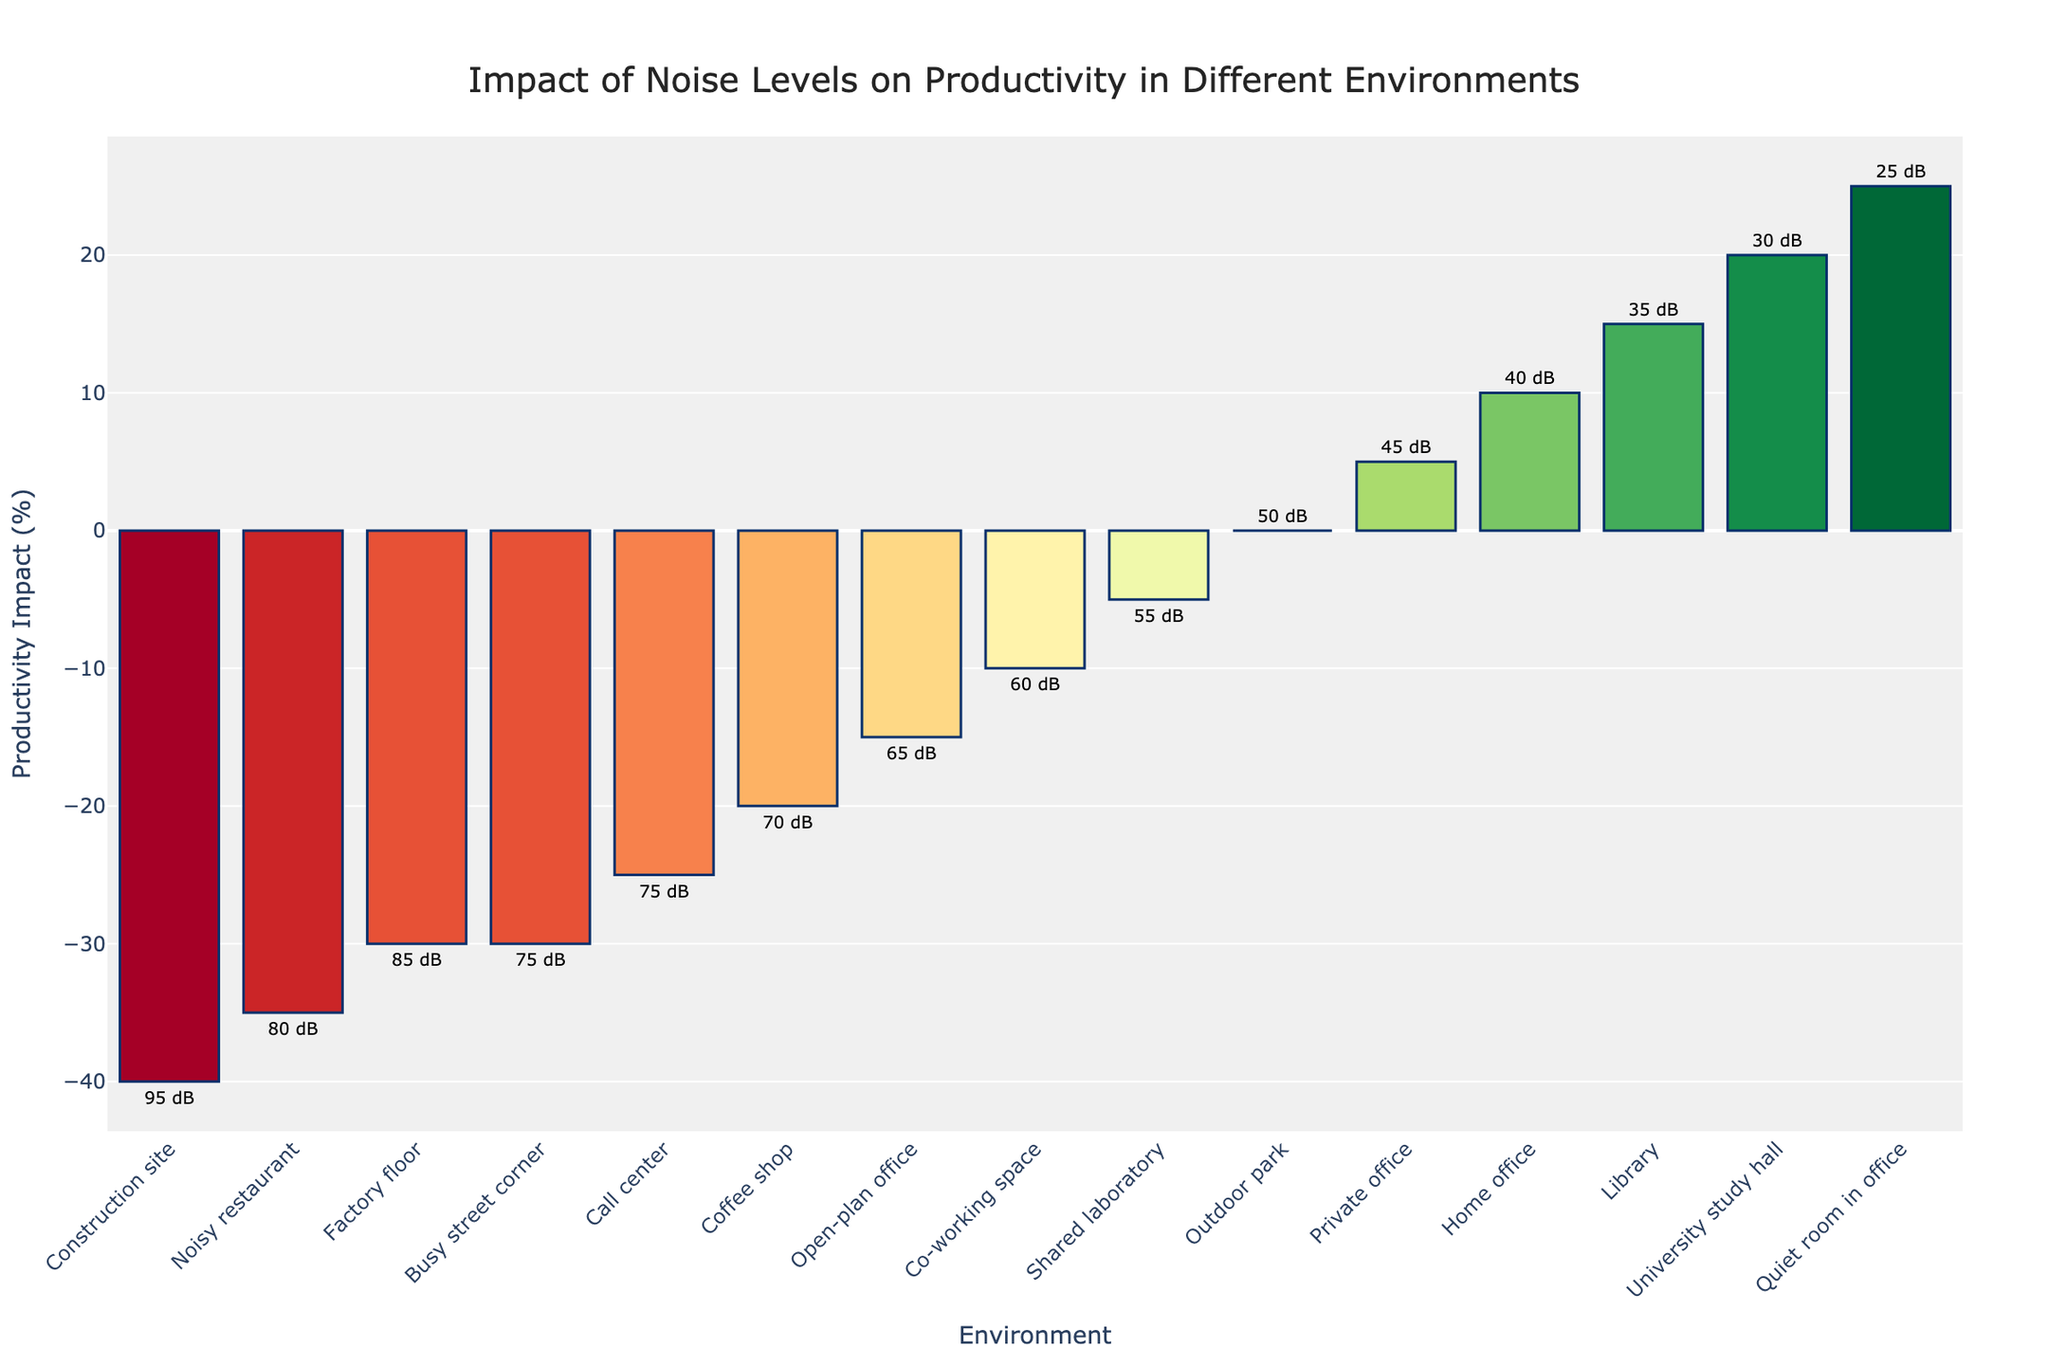Which environment has the highest positive impact on productivity? Look at the environment with the highest bar extending in the positive direction. The "University study hall" has the highest positive productivity impact.
Answer: University study hall Which environment has the lowest negative impact on productivity? Look at the environment with the least bar extending in the negative direction. The "Open-plan office" has the lowest negative productivity impact.
Answer: Open-plan office What is the difference in productivity impact between a private office and a shared laboratory? Find the bars for "Private office" and "Shared laboratory" and calculate the difference in their productivity impacts: 5 - (-5) = 10%.
Answer: 10% How much does productivity increase in a home office compared to a co-working space? Find the bars for "Home office" and "Co-working space" and calculate the difference in their productivity impacts: 10 - (-10) = 20%.
Answer: 20% What environments have a noise level of 70 dB or higher? Find the environments with text labels of 70 dB or higher: "Coffee shop", "Call center", "Construction site", "Noisy restaurant", "Busy street corner".
Answer: Coffee shop, Call center, Construction site, Noisy restaurant, Busy street corner Which environment has the greatest noise level but still shows positive productivity impact? Look for the environment with the highest noise level (dB) among those with positive productivity impact. The "Library" has 35 dB and +15% impact.
Answer: Library Compare the productivity impacts between the University study hall and the Construction site. Find and compare the values for "University study hall" and "Construction site". The productivity impact difference is 20 - (-40) = 60%.
Answer: 60% What’s the average productivity impact of environments with a noise level below 50 dB? Identify environments with noise less than 50 dB ("Private office", "Home office", "Library", "Quiet room in office", "University study hall"), add their impacts (5 + 10 + 15 + 25 + 20 = 75), and divide by the number of environments (75/5 = 15%).
Answer: 15% Which environment has the most negative impact on productivity, and what is its noise level? Look for the environment with the lowest bar extending in the negative direction. The "Construction site" has the most negative impact with a productivity impact of -40% and noise level of 95 dB.
Answer: Construction site, 95 dB 